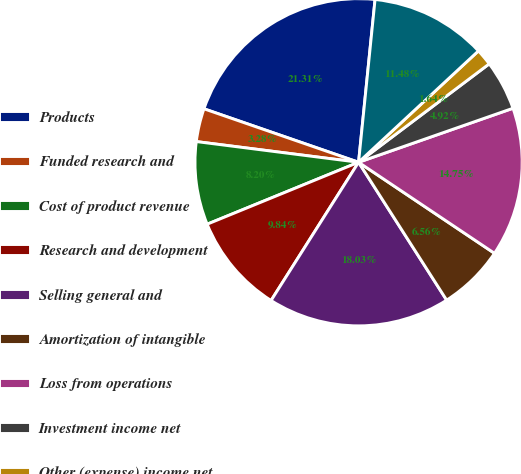<chart> <loc_0><loc_0><loc_500><loc_500><pie_chart><fcel>Products<fcel>Funded research and<fcel>Cost of product revenue<fcel>Research and development<fcel>Selling general and<fcel>Amortization of intangible<fcel>Loss from operations<fcel>Investment income net<fcel>Other (expense) income net<fcel>Loss before provision for<nl><fcel>21.31%<fcel>3.28%<fcel>8.2%<fcel>9.84%<fcel>18.03%<fcel>6.56%<fcel>14.75%<fcel>4.92%<fcel>1.64%<fcel>11.48%<nl></chart> 